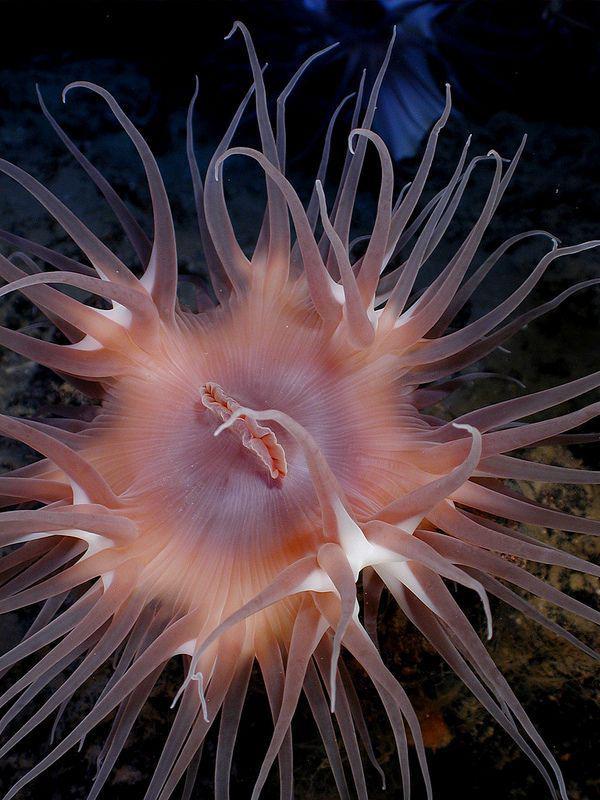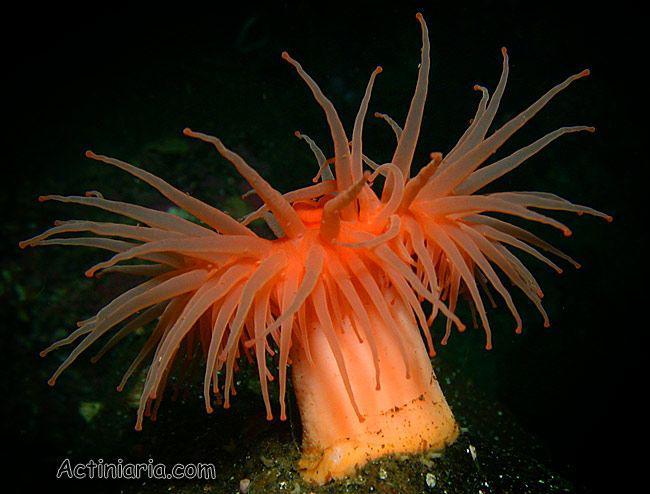The first image is the image on the left, the second image is the image on the right. Assess this claim about the two images: "One sea anemone has a visible mouth.". Correct or not? Answer yes or no. Yes. 